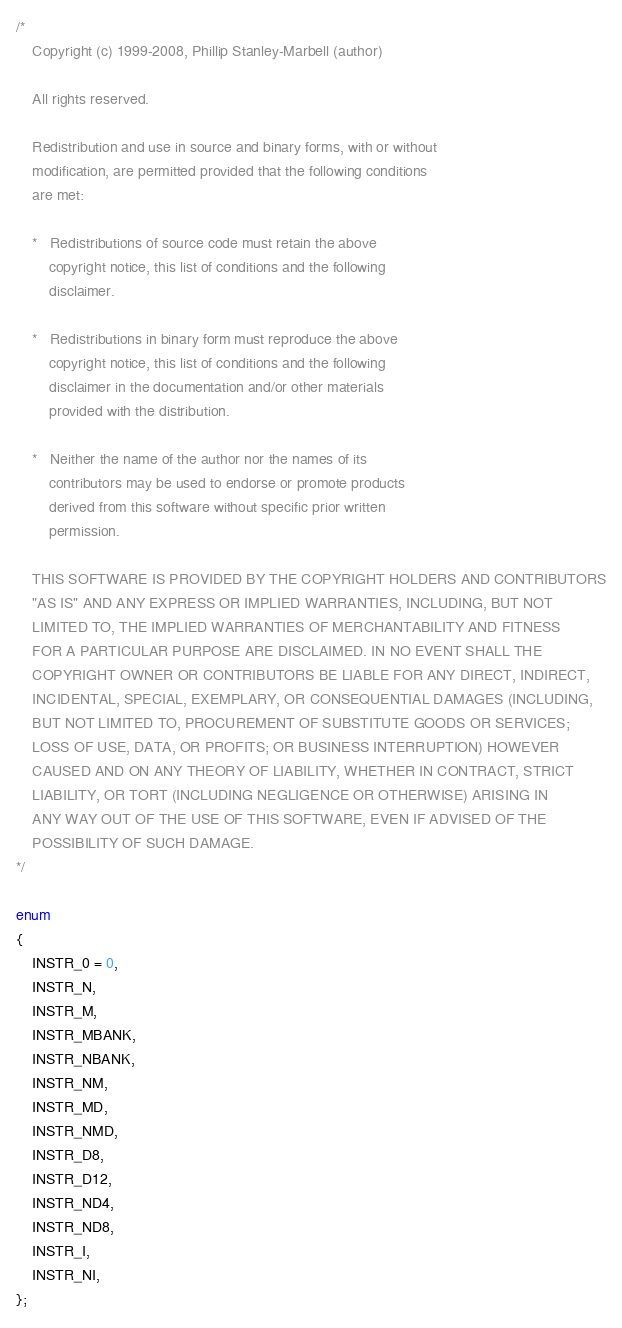<code> <loc_0><loc_0><loc_500><loc_500><_C_>/*
	Copyright (c) 1999-2008, Phillip Stanley-Marbell (author)
 
	All rights reserved.

	Redistribution and use in source and binary forms, with or without 
	modification, are permitted provided that the following conditions
	are met:

	*	Redistributions of source code must retain the above
		copyright notice, this list of conditions and the following
		disclaimer.

	*	Redistributions in binary form must reproduce the above
		copyright notice, this list of conditions and the following
		disclaimer in the documentation and/or other materials
		provided with the distribution.

	*	Neither the name of the author nor the names of its
		contributors may be used to endorse or promote products
		derived from this software without specific prior written 
		permission.

	THIS SOFTWARE IS PROVIDED BY THE COPYRIGHT HOLDERS AND CONTRIBUTORS
	"AS IS" AND ANY EXPRESS OR IMPLIED WARRANTIES, INCLUDING, BUT NOT
	LIMITED TO, THE IMPLIED WARRANTIES OF MERCHANTABILITY AND FITNESS
	FOR A PARTICULAR PURPOSE ARE DISCLAIMED. IN NO EVENT SHALL THE 
	COPYRIGHT OWNER OR CONTRIBUTORS BE LIABLE FOR ANY DIRECT, INDIRECT,
	INCIDENTAL, SPECIAL, EXEMPLARY, OR CONSEQUENTIAL DAMAGES (INCLUDING,
	BUT NOT LIMITED TO, PROCUREMENT OF SUBSTITUTE GOODS OR SERVICES; 
	LOSS OF USE, DATA, OR PROFITS; OR BUSINESS INTERRUPTION) HOWEVER 
	CAUSED AND ON ANY THEORY OF LIABILITY, WHETHER IN CONTRACT, STRICT
	LIABILITY, OR TORT (INCLUDING NEGLIGENCE OR OTHERWISE) ARISING IN 
	ANY WAY OUT OF THE USE OF THIS SOFTWARE, EVEN IF ADVISED OF THE 
	POSSIBILITY OF SUCH DAMAGE.
*/

enum
{
	INSTR_0 = 0,
	INSTR_N,
	INSTR_M,
	INSTR_MBANK,
	INSTR_NBANK,
	INSTR_NM,
	INSTR_MD,
	INSTR_NMD,
	INSTR_D8,
	INSTR_D12,
	INSTR_ND4,
	INSTR_ND8,
	INSTR_I,
	INSTR_NI,
};
</code> 